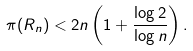Convert formula to latex. <formula><loc_0><loc_0><loc_500><loc_500>\pi ( R _ { n } ) < 2 n \left ( 1 + \frac { \log 2 } { \log n } \right ) .</formula> 